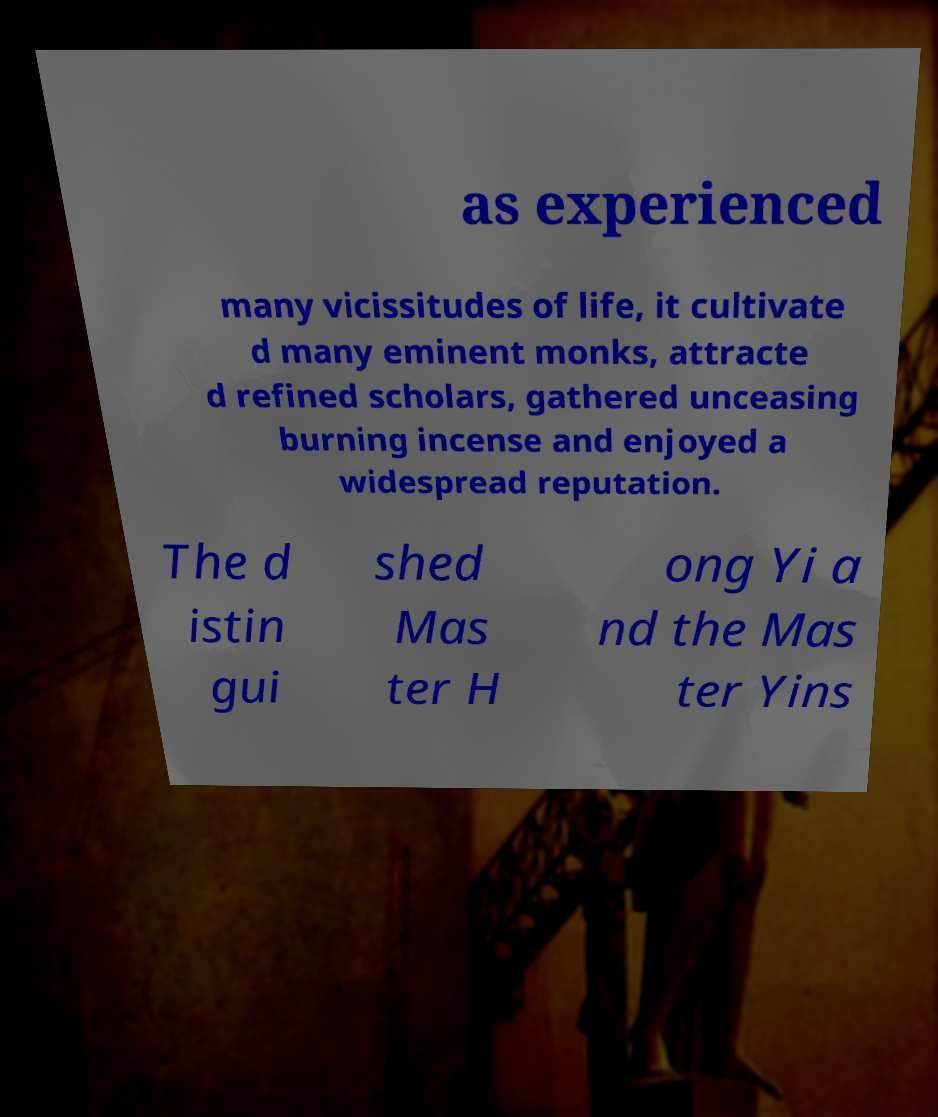Can you read and provide the text displayed in the image?This photo seems to have some interesting text. Can you extract and type it out for me? as experienced many vicissitudes of life, it cultivate d many eminent monks, attracte d refined scholars, gathered unceasing burning incense and enjoyed a widespread reputation. The d istin gui shed Mas ter H ong Yi a nd the Mas ter Yins 